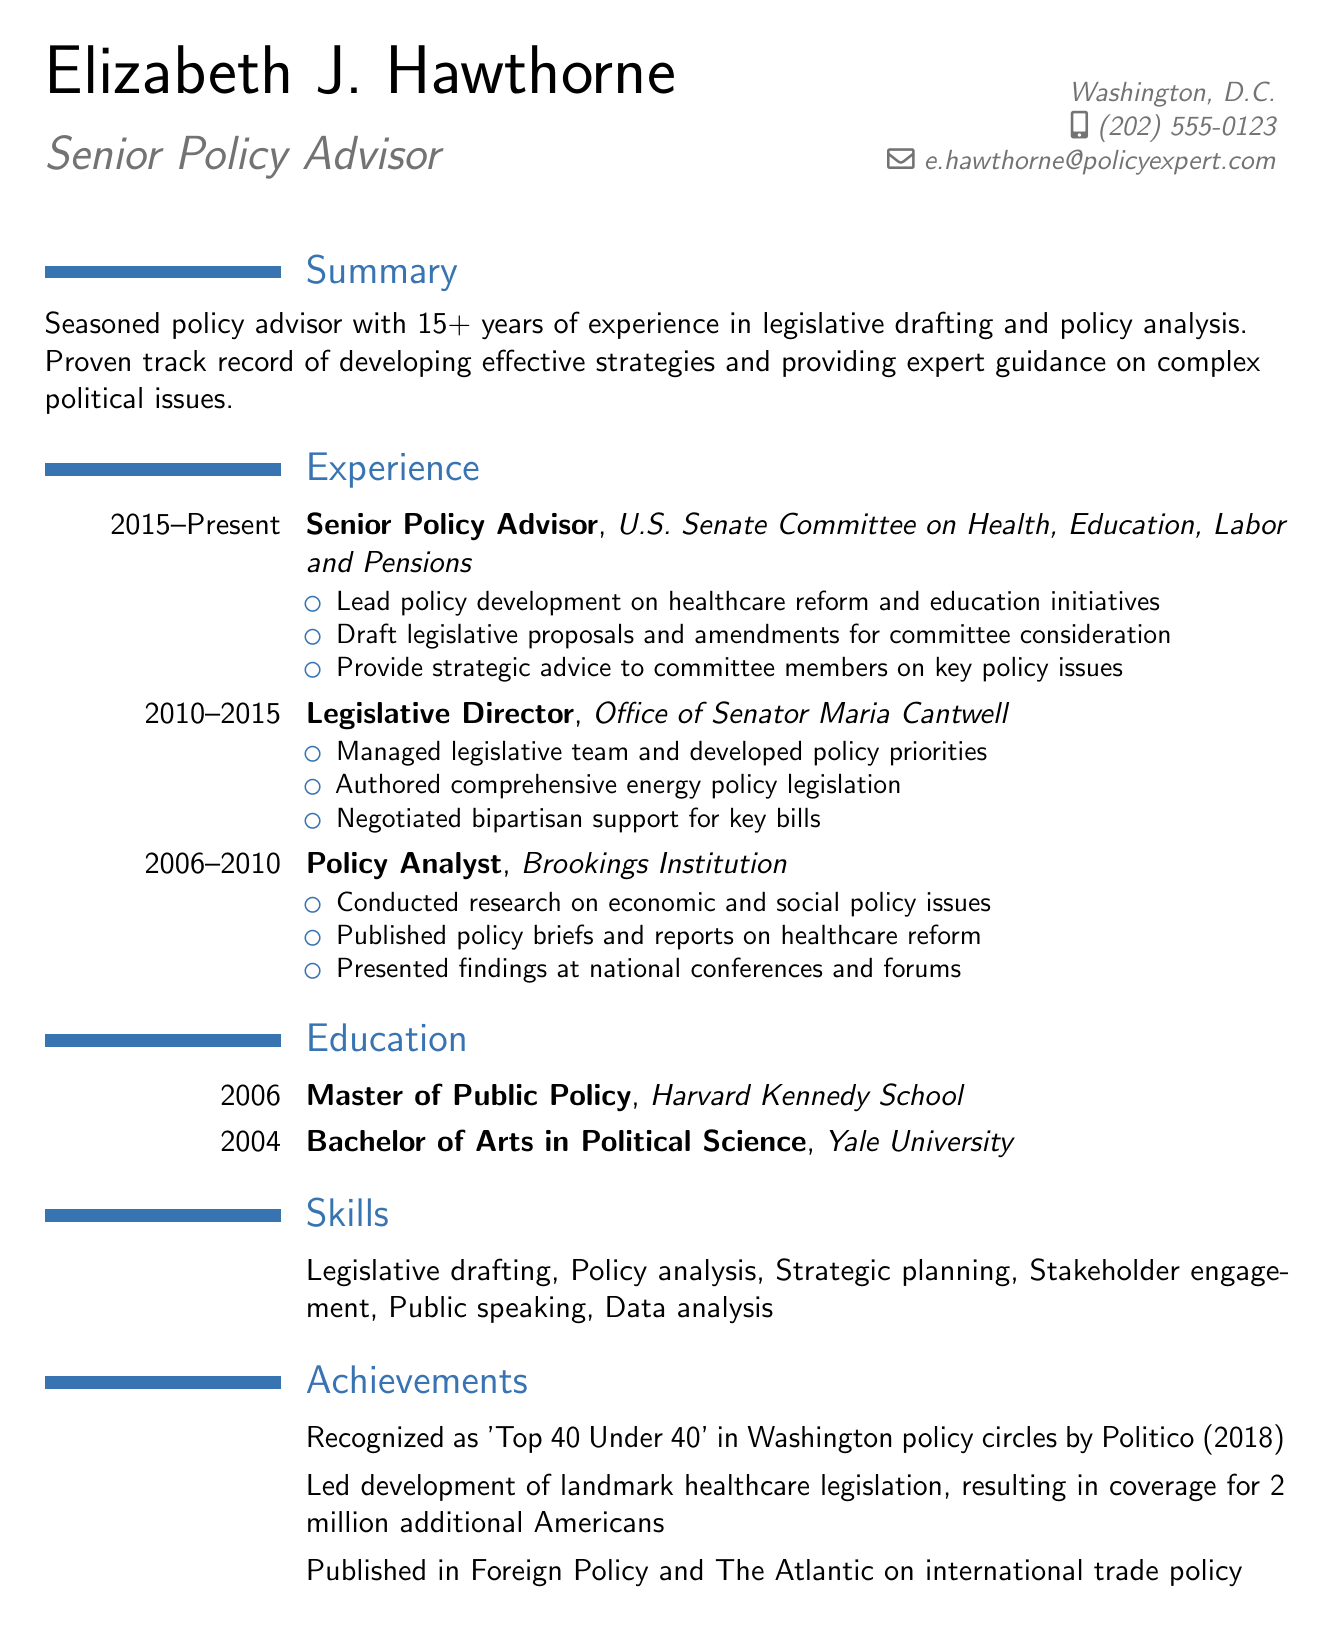What is Elizabeth J. Hawthorne's current position? The current position is listed under the work experience section as "Senior Policy Advisor."
Answer: Senior Policy Advisor How many years of experience does Elizabeth J. Hawthorne have? The summary section mentions over 15 years of experience in policy-related fields.
Answer: 15+ years Which organization did Elizabeth J. Hawthorne work for as a Policy Analyst? The work experience section lists "Brookings Institution" as the organization during the tenure as a Policy Analyst.
Answer: Brookings Institution What significant healthcare legislation did Elizabeth J. Hawthorne help develop? The achievements section provides information about the landmark healthcare legislation that resulted in coverage for additional Americans.
Answer: Landmark healthcare legislation Which degree did Elizabeth J. Hawthorne acquire from Harvard Kennedy School? The education section indicates that she received a Master of Public Policy degree from Harvard Kennedy School.
Answer: Master of Public Policy In what year did Elizabeth J. Hawthorne complete her Bachelor's degree? The education section specifies that she completed her Bachelor's degree in 2004.
Answer: 2004 What recognition did Elizabeth J. Hawthorne receive in 2018? The achievements section states that she was recognized as "Top 40 Under 40" in Washington policy circles by Politico in 2018.
Answer: Top 40 Under 40 How many key bills did Elizabeth J. Hawthorne negotiate bipartisan support for? The work experience entry for her role as Legislative Director states she negotiated bipartisan support for key bills, but does not specify a number.
Answer: Key bills (unspecified) What are two skills highlighted in Elizabeth J. Hawthorne's resume? The skills section lists multiple skills, including legislative drafting and policy analysis.
Answer: Legislative drafting, Policy analysis 